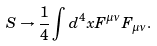Convert formula to latex. <formula><loc_0><loc_0><loc_500><loc_500>S \rightarrow \frac { 1 } { 4 } \int d ^ { 4 } x F ^ { \mu \nu } F _ { \mu \nu } .</formula> 